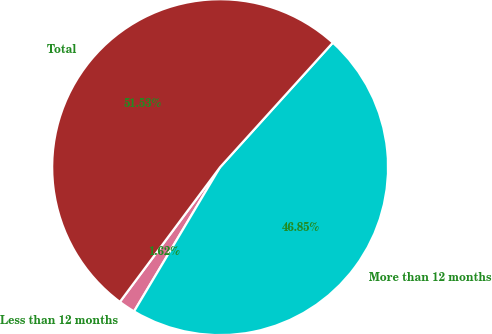Convert chart. <chart><loc_0><loc_0><loc_500><loc_500><pie_chart><fcel>Less than 12 months<fcel>More than 12 months<fcel>Total<nl><fcel>1.62%<fcel>46.85%<fcel>51.53%<nl></chart> 